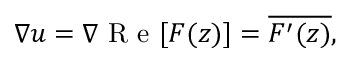Convert formula to latex. <formula><loc_0><loc_0><loc_500><loc_500>\nabla u = \nabla R e [ F ( z ) ] = \overline { { F ^ { \prime } ( z ) } } ,</formula> 